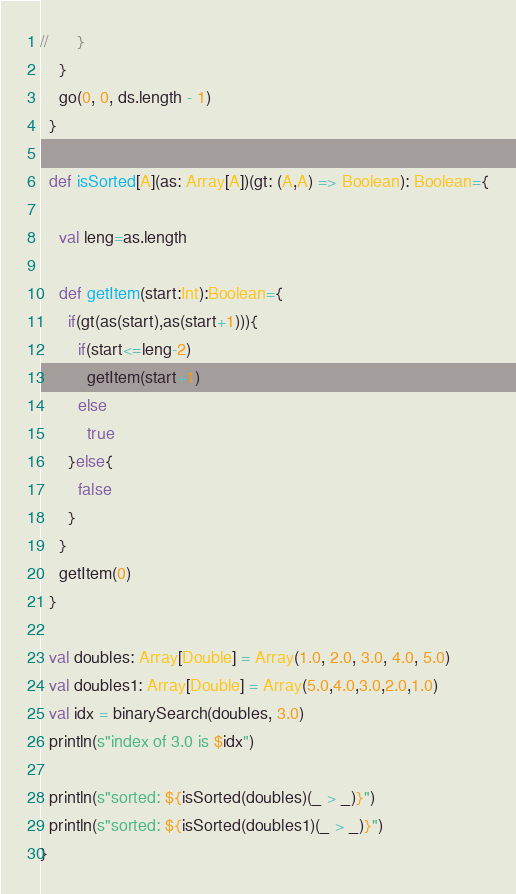Convert code to text. <code><loc_0><loc_0><loc_500><loc_500><_Scala_>//      }
    }
    go(0, 0, ds.length - 1)
  }

  def isSorted[A](as: Array[A])(gt: (A,A) => Boolean): Boolean={

    val leng=as.length

    def getItem(start:Int):Boolean={
      if(gt(as(start),as(start+1))){
        if(start<=leng-2)
          getItem(start+1)
        else
          true
      }else{
        false
      }
    }
    getItem(0)
  }

  val doubles: Array[Double] = Array(1.0, 2.0, 3.0, 4.0, 5.0)
  val doubles1: Array[Double] = Array(5.0,4.0,3.0,2.0,1.0)
  val idx = binarySearch(doubles, 3.0)
  println(s"index of 3.0 is $idx")

  println(s"sorted: ${isSorted(doubles)(_ > _)}")
  println(s"sorted: ${isSorted(doubles1)(_ > _)}")
}
</code> 